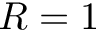<formula> <loc_0><loc_0><loc_500><loc_500>R = 1</formula> 